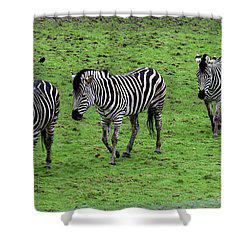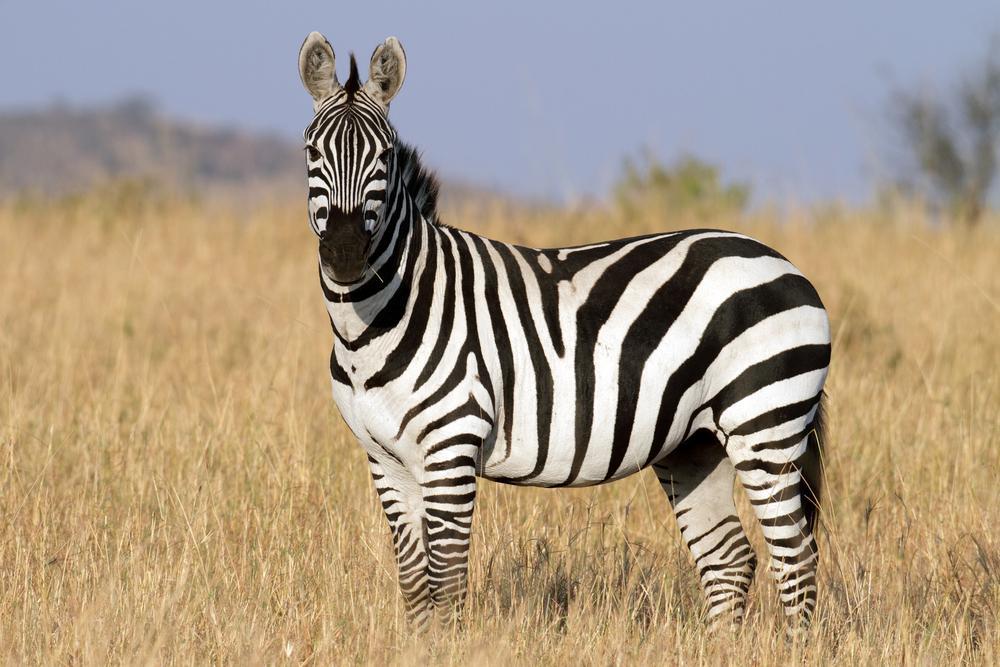The first image is the image on the left, the second image is the image on the right. Assess this claim about the two images: "Three zebras are nicely lined up in both of the pictures.". Correct or not? Answer yes or no. No. 